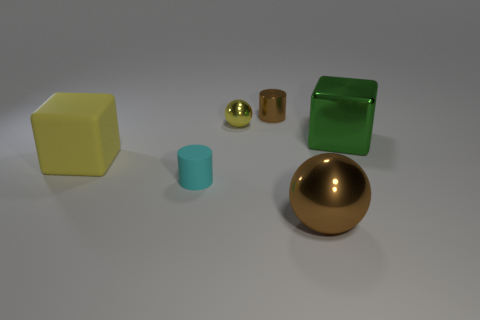What shape is the object behind the small shiny thing that is left of the metal cylinder?
Provide a short and direct response. Cylinder. Are there fewer tiny cyan cylinders than yellow objects?
Keep it short and to the point. Yes. Is the material of the cyan object the same as the big yellow thing?
Your answer should be very brief. Yes. What is the color of the metallic object that is to the right of the brown cylinder and behind the large matte thing?
Offer a very short reply. Green. Are there any metal spheres that have the same size as the cyan matte thing?
Offer a very short reply. Yes. There is a metallic thing behind the metallic ball to the left of the brown cylinder; what is its size?
Give a very brief answer. Small. Are there fewer cyan rubber objects right of the small rubber cylinder than large green blocks?
Keep it short and to the point. Yes. Does the small ball have the same color as the large rubber thing?
Your answer should be compact. Yes. How big is the cyan object?
Provide a succinct answer. Small. What number of spheres have the same color as the metal cylinder?
Ensure brevity in your answer.  1. 